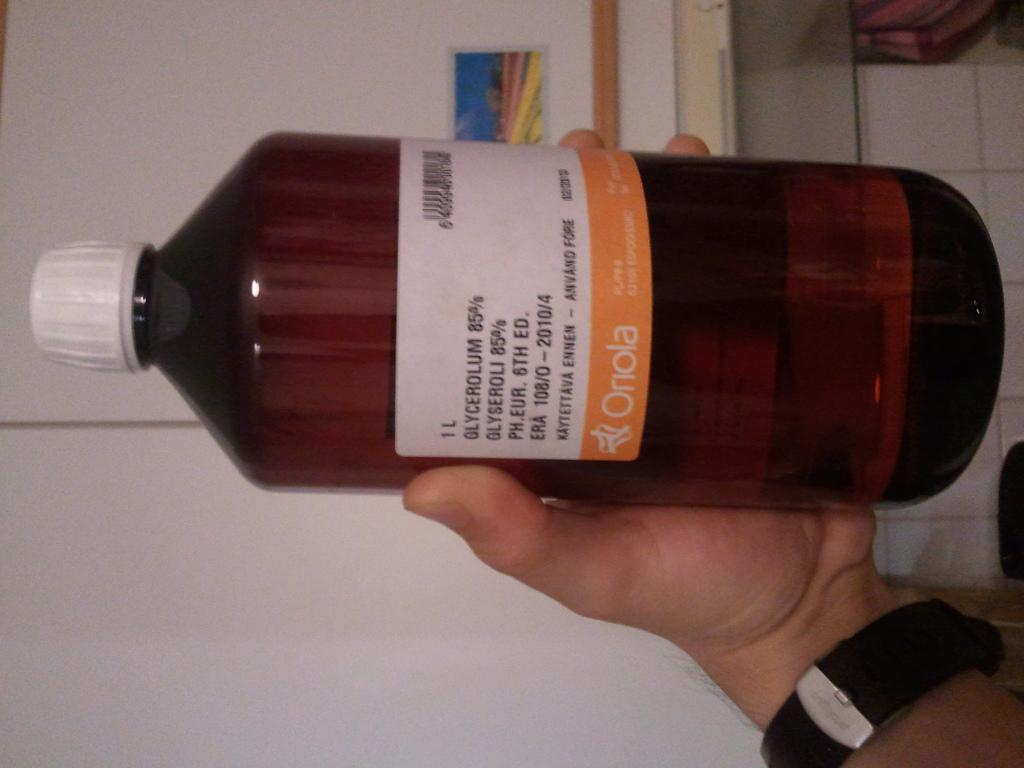<image>
Present a compact description of the photo's key features. a bottle of medicine made by the company oriola 